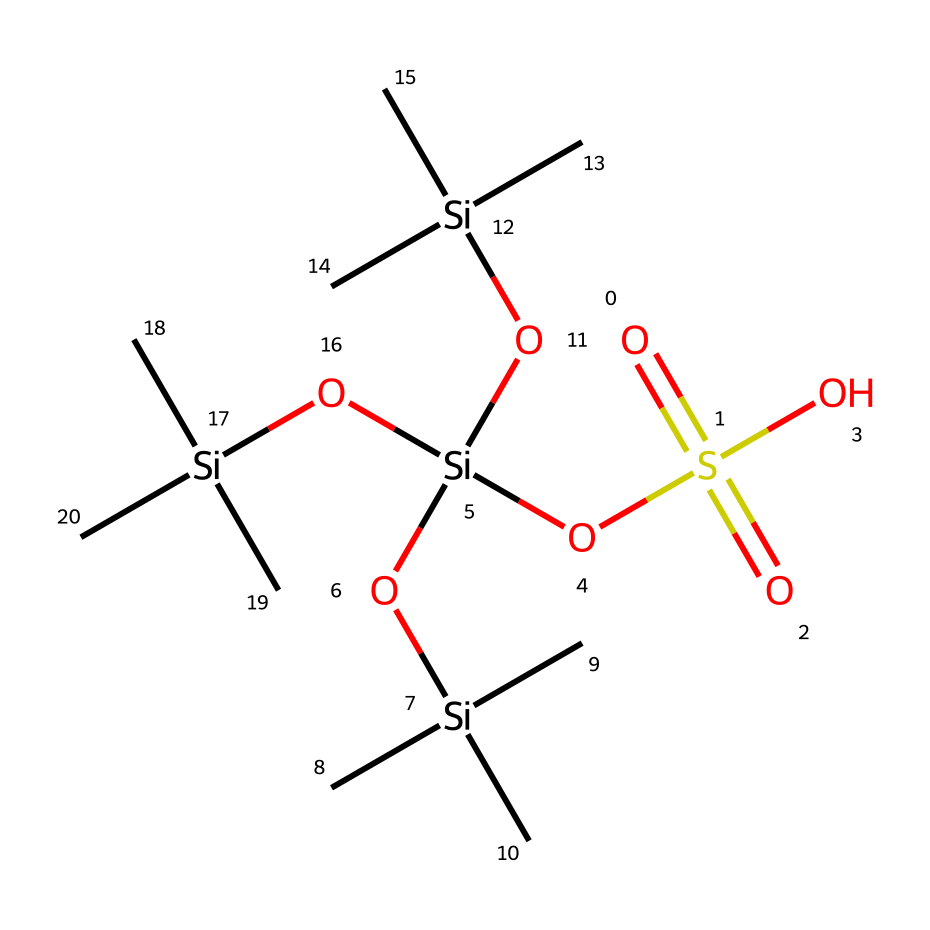How many silicon atoms are in this chemical? The chemical's structure includes multiple silicon atoms that can be identified by the 'Si' notation. Counting the instances of 'Si', there are four silicon atoms present in the structure.
Answer: four What is the oxidation state of sulfur in this compound? The sulfur atom is attached to four oxygen atoms, with two of them representing double bonds as indicated by the '=' signs in the SMILES notation. The -O=S(=O) part shows that sulfur is in a +6 oxidation state.
Answer: +6 Which type of non-Newtonian behavior does this fluid exhibit? Given that the structure indicates a shear-thickening behavior, this fluid's viscosity increases with applied shear stress, which is a characteristic of non-Newtonian fluids.
Answer: shear-thickening What functional groups are present in this chemical? Reviewing the chemical structure and its SMILES representation reveals that there are sulfonic acid (-SO3H) groups and silyl ether groups present, providing key functionalities.
Answer: sulfonic acid, silyl ether How many hydroxyl (OH) groups are present in this chemical? By examining the structure, each silicon atom is attached to hydroxyl groups, and by counting, there are a total of three hydroxyl groups linked to the four silicon atoms in the structure.
Answer: three What role do silyl groups play in this fluid? Silyl groups contribute to the shear-thickening characteristic of the non-Newtonian fluid, affecting the intermolecular forces and network structure under stress, thus increasing viscosity.
Answer: increase viscosity 